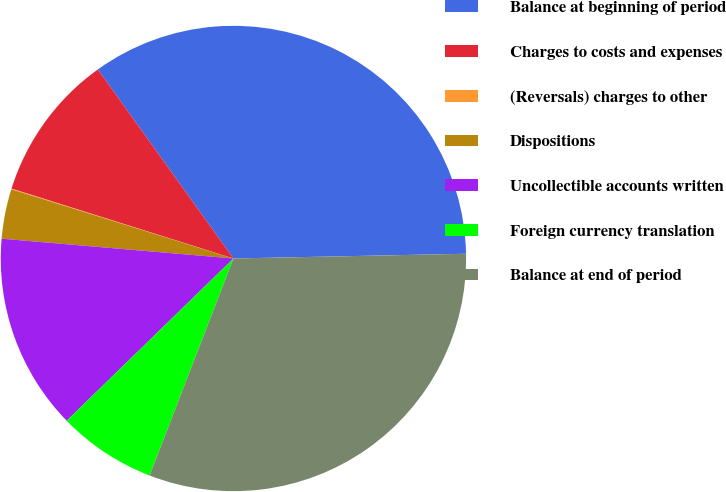Convert chart. <chart><loc_0><loc_0><loc_500><loc_500><pie_chart><fcel>Balance at beginning of period<fcel>Charges to costs and expenses<fcel>(Reversals) charges to other<fcel>Dispositions<fcel>Uncollectible accounts written<fcel>Foreign currency translation<fcel>Balance at end of period<nl><fcel>34.58%<fcel>10.24%<fcel>0.05%<fcel>3.45%<fcel>13.64%<fcel>6.85%<fcel>31.19%<nl></chart> 